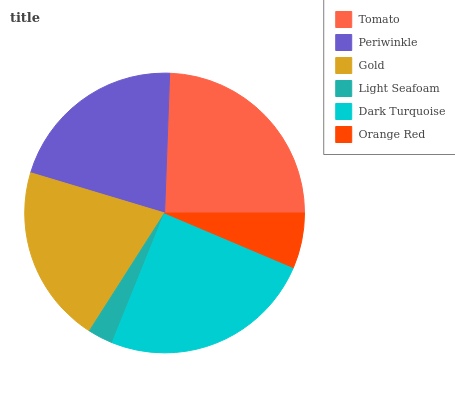Is Light Seafoam the minimum?
Answer yes or no. Yes. Is Dark Turquoise the maximum?
Answer yes or no. Yes. Is Periwinkle the minimum?
Answer yes or no. No. Is Periwinkle the maximum?
Answer yes or no. No. Is Tomato greater than Periwinkle?
Answer yes or no. Yes. Is Periwinkle less than Tomato?
Answer yes or no. Yes. Is Periwinkle greater than Tomato?
Answer yes or no. No. Is Tomato less than Periwinkle?
Answer yes or no. No. Is Periwinkle the high median?
Answer yes or no. Yes. Is Gold the low median?
Answer yes or no. Yes. Is Tomato the high median?
Answer yes or no. No. Is Dark Turquoise the low median?
Answer yes or no. No. 